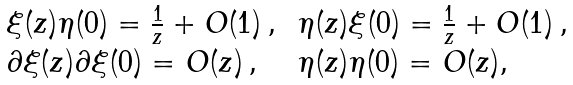<formula> <loc_0><loc_0><loc_500><loc_500>\begin{array} { l l } \xi ( z ) \eta ( 0 ) = \frac { 1 } { z } + O ( 1 ) \, , \, & \eta ( z ) \xi ( 0 ) = \frac { 1 } { z } + O ( 1 ) \, , \\ \partial \xi ( z ) \partial \xi ( 0 ) = O ( z ) \, , & \eta ( z ) \eta ( 0 ) = O ( z ) , \end{array}</formula> 